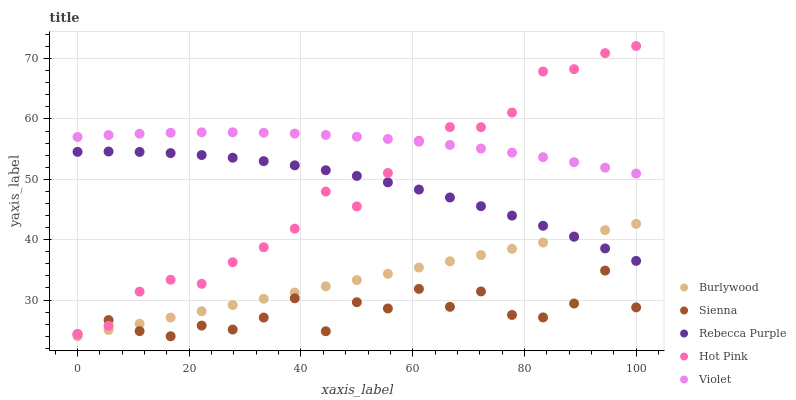Does Sienna have the minimum area under the curve?
Answer yes or no. Yes. Does Violet have the maximum area under the curve?
Answer yes or no. Yes. Does Hot Pink have the minimum area under the curve?
Answer yes or no. No. Does Hot Pink have the maximum area under the curve?
Answer yes or no. No. Is Burlywood the smoothest?
Answer yes or no. Yes. Is Sienna the roughest?
Answer yes or no. Yes. Is Hot Pink the smoothest?
Answer yes or no. No. Is Hot Pink the roughest?
Answer yes or no. No. Does Burlywood have the lowest value?
Answer yes or no. Yes. Does Hot Pink have the lowest value?
Answer yes or no. No. Does Hot Pink have the highest value?
Answer yes or no. Yes. Does Sienna have the highest value?
Answer yes or no. No. Is Sienna less than Rebecca Purple?
Answer yes or no. Yes. Is Violet greater than Burlywood?
Answer yes or no. Yes. Does Hot Pink intersect Rebecca Purple?
Answer yes or no. Yes. Is Hot Pink less than Rebecca Purple?
Answer yes or no. No. Is Hot Pink greater than Rebecca Purple?
Answer yes or no. No. Does Sienna intersect Rebecca Purple?
Answer yes or no. No. 